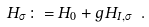<formula> <loc_0><loc_0><loc_500><loc_500>H _ { \sigma } \colon = H _ { 0 } + g H _ { I , \sigma } \ .</formula> 